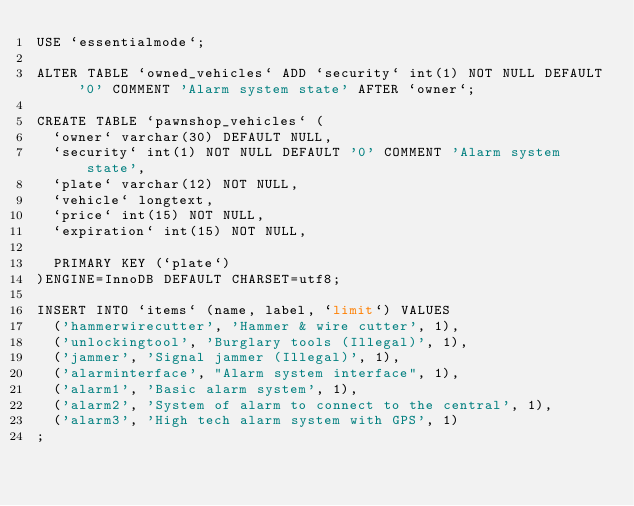<code> <loc_0><loc_0><loc_500><loc_500><_SQL_>USE `essentialmode`;

ALTER TABLE `owned_vehicles` ADD `security` int(1) NOT NULL DEFAULT '0' COMMENT 'Alarm system state' AFTER `owner`;

CREATE TABLE `pawnshop_vehicles` (
	`owner` varchar(30) DEFAULT NULL,
	`security` int(1) NOT NULL DEFAULT '0' COMMENT 'Alarm system state',
	`plate` varchar(12) NOT NULL,
	`vehicle` longtext,
	`price` int(15) NOT NULL,
	`expiration` int(15) NOT NULL,

	PRIMARY KEY (`plate`)
)ENGINE=InnoDB DEFAULT CHARSET=utf8;

INSERT INTO `items` (name, label, `limit`) VALUES
	('hammerwirecutter', 'Hammer & wire cutter', 1),
	('unlockingtool', 'Burglary tools (Illegal)', 1),
	('jammer', 'Signal jammer (Illegal)', 1),
	('alarminterface', "Alarm system interface", 1),
	('alarm1', 'Basic alarm system', 1),
	('alarm2', 'System of alarm to connect to the central', 1),
	('alarm3', 'High tech alarm system with GPS', 1)
;
</code> 